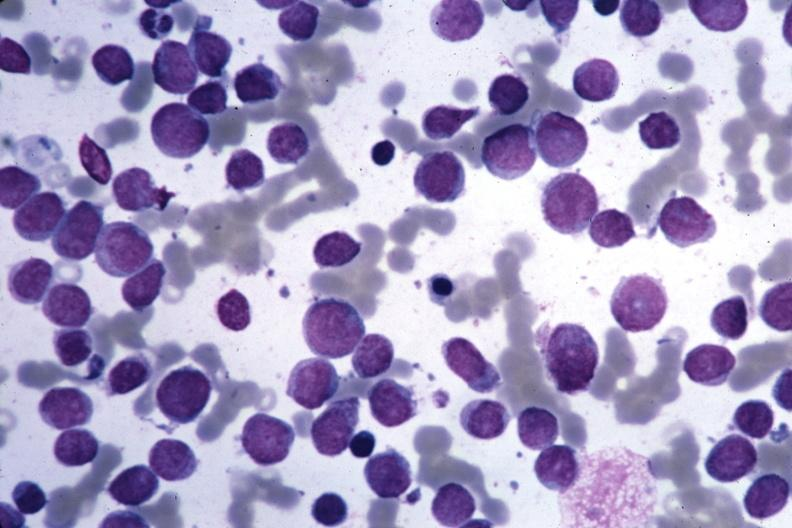does atrophy show wrights easily seen blastic cells?
Answer the question using a single word or phrase. No 